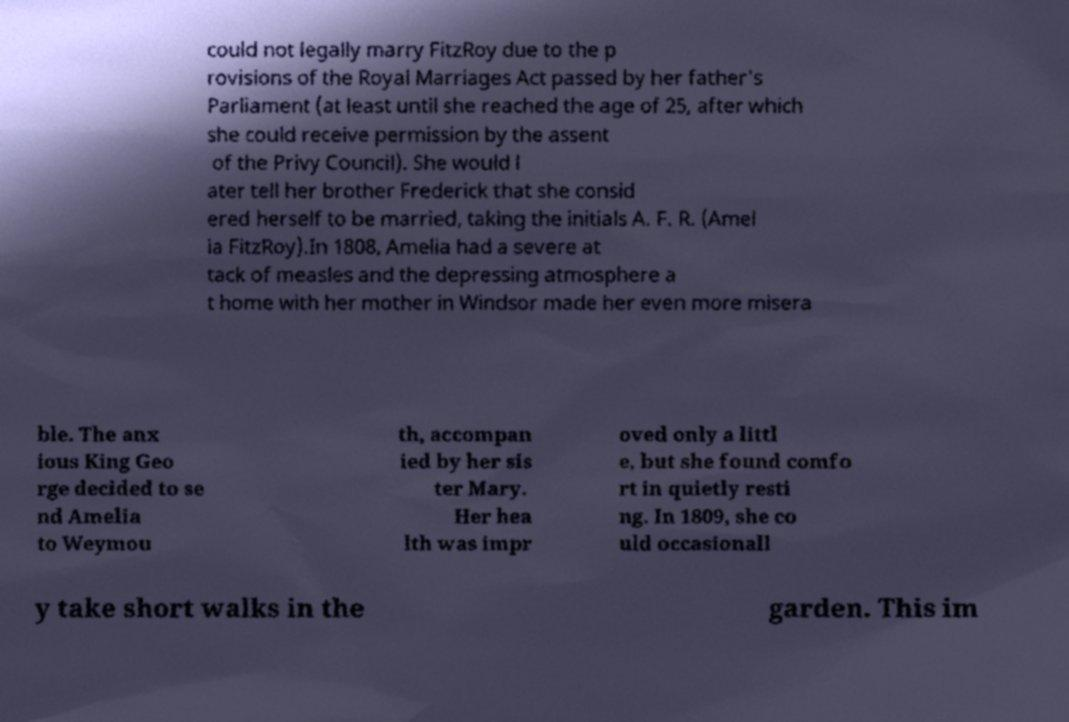What messages or text are displayed in this image? I need them in a readable, typed format. could not legally marry FitzRoy due to the p rovisions of the Royal Marriages Act passed by her father's Parliament (at least until she reached the age of 25, after which she could receive permission by the assent of the Privy Council). She would l ater tell her brother Frederick that she consid ered herself to be married, taking the initials A. F. R. (Amel ia FitzRoy).In 1808, Amelia had a severe at tack of measles and the depressing atmosphere a t home with her mother in Windsor made her even more misera ble. The anx ious King Geo rge decided to se nd Amelia to Weymou th, accompan ied by her sis ter Mary. Her hea lth was impr oved only a littl e, but she found comfo rt in quietly resti ng. In 1809, she co uld occasionall y take short walks in the garden. This im 